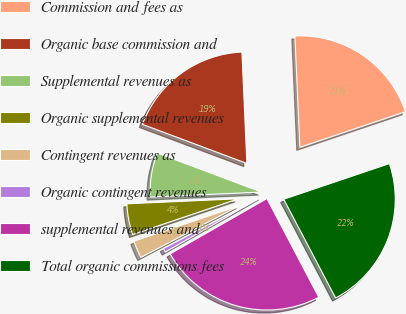<chart> <loc_0><loc_0><loc_500><loc_500><pie_chart><fcel>Commission and fees as<fcel>Organic base commission and<fcel>Supplemental revenues as<fcel>Organic supplemental revenues<fcel>Contingent revenues as<fcel>Organic contingent revenues<fcel>supplemental revenues and<fcel>Total organic commissions fees<nl><fcel>20.53%<fcel>18.59%<fcel>6.41%<fcel>4.47%<fcel>2.52%<fcel>0.57%<fcel>24.43%<fcel>22.48%<nl></chart> 